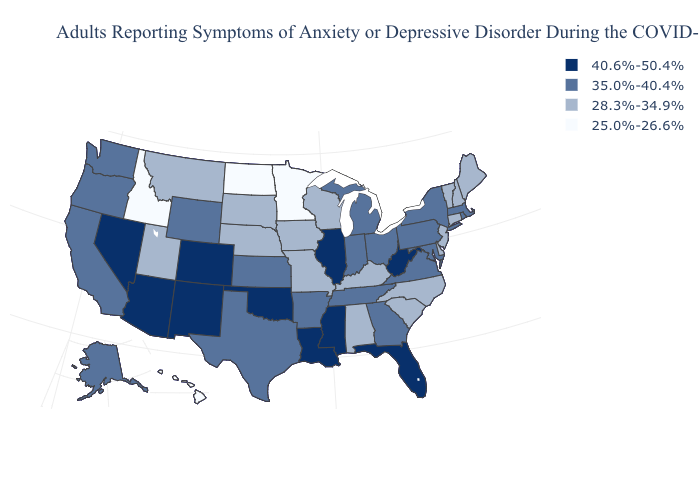What is the value of Washington?
Answer briefly. 35.0%-40.4%. What is the value of Arizona?
Answer briefly. 40.6%-50.4%. Name the states that have a value in the range 40.6%-50.4%?
Quick response, please. Arizona, Colorado, Florida, Illinois, Louisiana, Mississippi, Nevada, New Mexico, Oklahoma, West Virginia. Name the states that have a value in the range 28.3%-34.9%?
Short answer required. Alabama, Connecticut, Delaware, Iowa, Kentucky, Maine, Missouri, Montana, Nebraska, New Hampshire, New Jersey, North Carolina, South Carolina, South Dakota, Utah, Vermont, Wisconsin. Among the states that border New Hampshire , which have the lowest value?
Short answer required. Maine, Vermont. How many symbols are there in the legend?
Concise answer only. 4. Name the states that have a value in the range 40.6%-50.4%?
Quick response, please. Arizona, Colorado, Florida, Illinois, Louisiana, Mississippi, Nevada, New Mexico, Oklahoma, West Virginia. Is the legend a continuous bar?
Write a very short answer. No. Name the states that have a value in the range 25.0%-26.6%?
Quick response, please. Hawaii, Idaho, Minnesota, North Dakota. Does Minnesota have the lowest value in the MidWest?
Answer briefly. Yes. Which states have the lowest value in the South?
Quick response, please. Alabama, Delaware, Kentucky, North Carolina, South Carolina. What is the highest value in the MidWest ?
Write a very short answer. 40.6%-50.4%. Does Idaho have the lowest value in the USA?
Be succinct. Yes. Name the states that have a value in the range 40.6%-50.4%?
Write a very short answer. Arizona, Colorado, Florida, Illinois, Louisiana, Mississippi, Nevada, New Mexico, Oklahoma, West Virginia. What is the value of Ohio?
Short answer required. 35.0%-40.4%. 